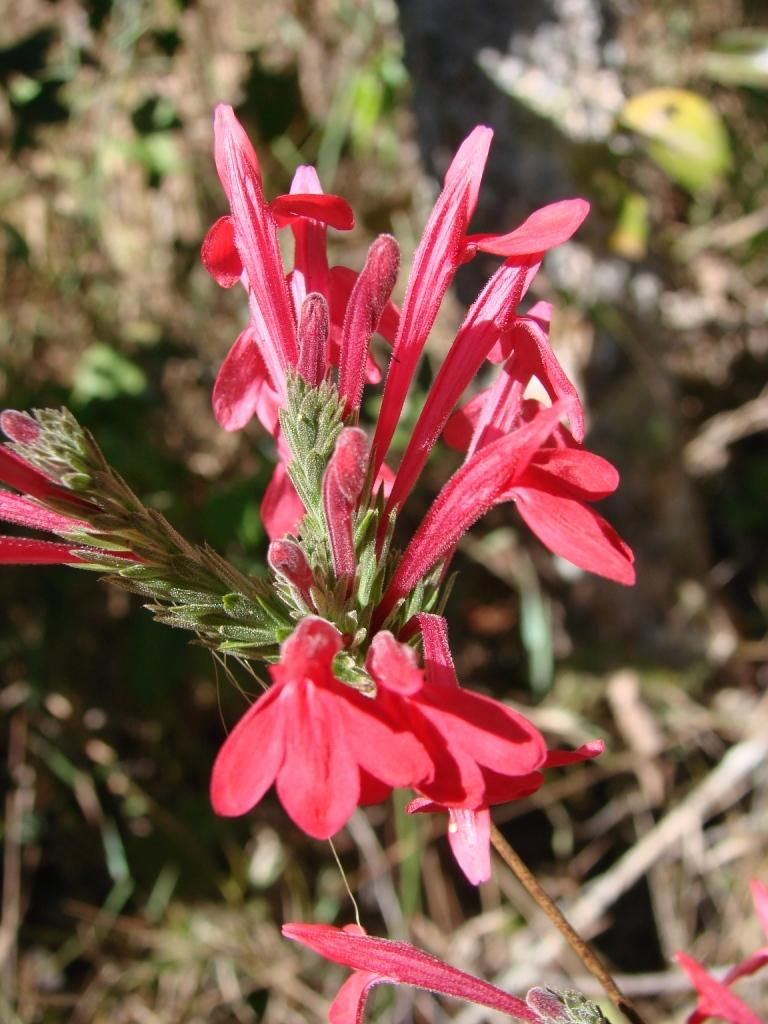What is the main subject of the image? The main subject of the image is a bunch of flowers. Can you describe any specific details about the flowers? Yes, there are buds on the stem of a plant in the image. What is the price of the brick that the grandmother is holding in the image? There is no grandmother or brick present in the image; it features a bunch of flowers with buds on the stem of a plant. 